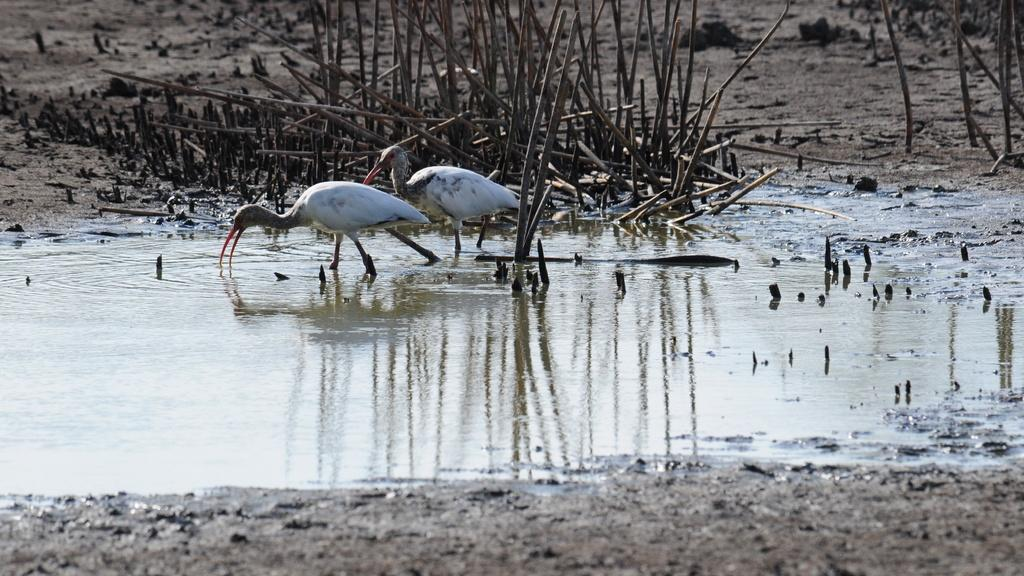What is the main subject in the center of the image? There are cranes in the center of the image. What is located at the bottom of the image? There is water at the bottom of the image. What can be seen in the background of the image? There are sticks visible in the background of the image. What type of beam is being used by the committee in the image? There is no committee or beam present in the image; it features cranes and water. How many nets are visible in the image? There are no nets present in the image. 